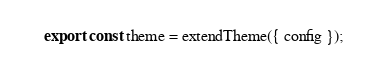Convert code to text. <code><loc_0><loc_0><loc_500><loc_500><_TypeScript_>export const theme = extendTheme({ config });
</code> 